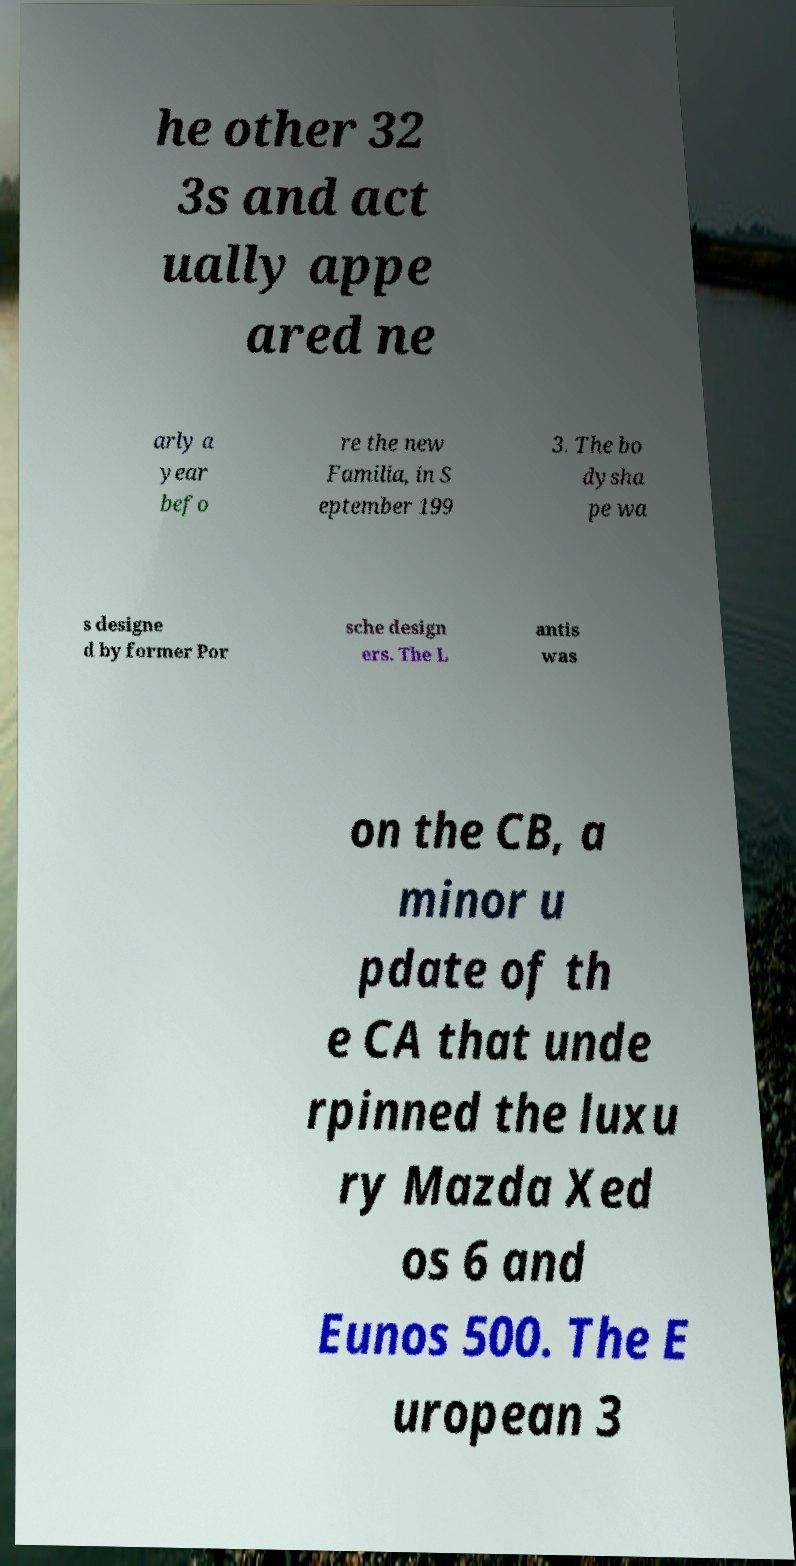I need the written content from this picture converted into text. Can you do that? he other 32 3s and act ually appe ared ne arly a year befo re the new Familia, in S eptember 199 3. The bo dysha pe wa s designe d by former Por sche design ers. The L antis was on the CB, a minor u pdate of th e CA that unde rpinned the luxu ry Mazda Xed os 6 and Eunos 500. The E uropean 3 